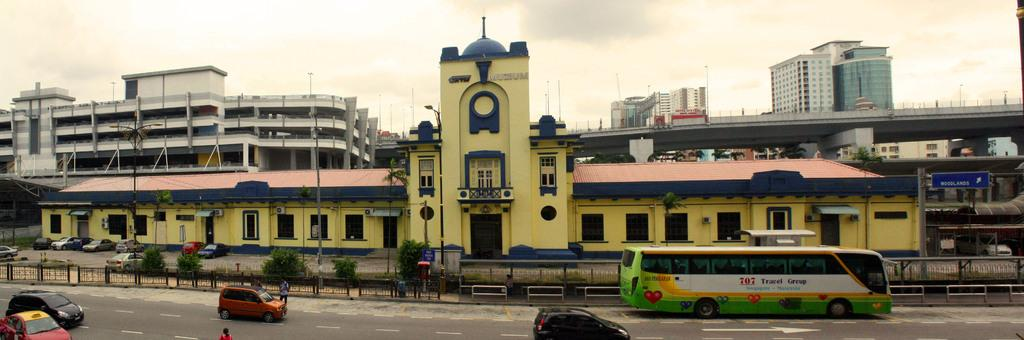What is located in the middle of the image? There are buildings, a bridge, pillars, and poles in the middle of the image. What can be seen at the bottom of the image? At the bottom of the image, there are vehicles, people, plants, and cars. What is present at the bottom of the image? There is a road at the bottom of the image. What is visible at the top of the image? At the top of the image, there is sky and clouds. What type of loaf is being pushed by the people at the bottom of the image? There is no loaf present in the image, and no one is pushing anything. How does the form of the clouds at the top of the image change over time? The image is a still photograph, so we cannot observe any changes in the clouds' form over time. 